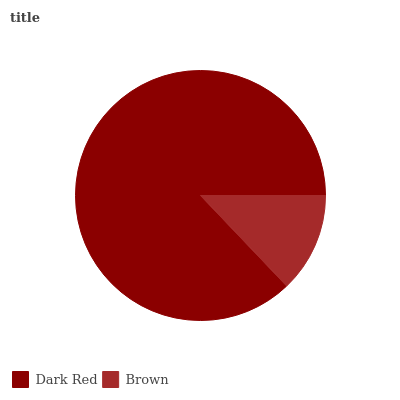Is Brown the minimum?
Answer yes or no. Yes. Is Dark Red the maximum?
Answer yes or no. Yes. Is Brown the maximum?
Answer yes or no. No. Is Dark Red greater than Brown?
Answer yes or no. Yes. Is Brown less than Dark Red?
Answer yes or no. Yes. Is Brown greater than Dark Red?
Answer yes or no. No. Is Dark Red less than Brown?
Answer yes or no. No. Is Dark Red the high median?
Answer yes or no. Yes. Is Brown the low median?
Answer yes or no. Yes. Is Brown the high median?
Answer yes or no. No. Is Dark Red the low median?
Answer yes or no. No. 